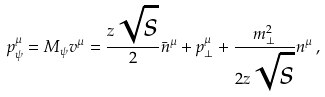<formula> <loc_0><loc_0><loc_500><loc_500>p _ { \psi } ^ { \mu } = M _ { \psi } v ^ { \mu } = \frac { z \sqrt { s } } { 2 } \bar { n } ^ { \mu } + p _ { \perp } ^ { \mu } + \frac { m _ { \perp } ^ { 2 } } { 2 z \sqrt { s } } n ^ { \mu } \, ,</formula> 